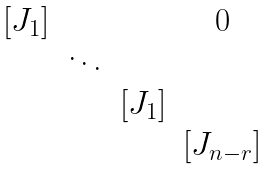<formula> <loc_0><loc_0><loc_500><loc_500>\begin{matrix} [ J _ { 1 } ] & & & 0 \\ & \ddots & & \\ & & [ J _ { 1 } ] & \\ & & & [ J _ { n - r } ] \end{matrix}</formula> 